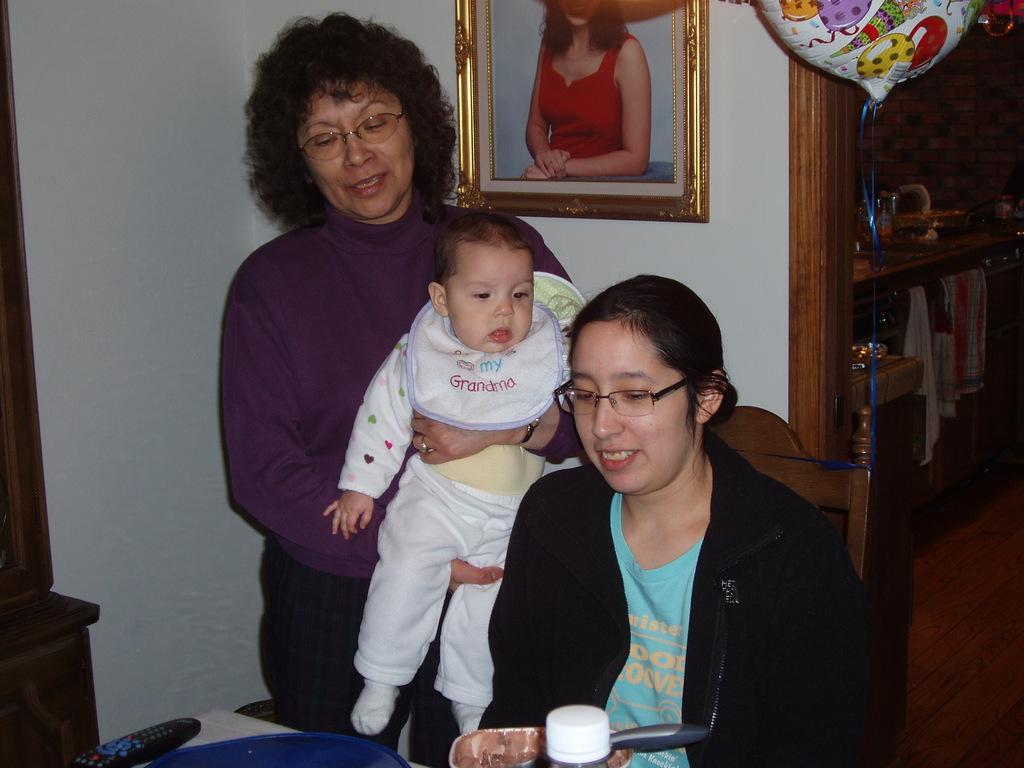Please provide a concise description of this image. In this image, I can see the woman sitting and smiling. At the bottom of the image, I can see a remote and few objects are placed on the table. Here is another woman standing and carrying a baby. This is a photo frame, which is attached to a wall. I think this is a balloon. On the right side of the image, I can see the clothes hanging. This looks like a kitchen room. On the left side of the image, that looks like a wooden object. 